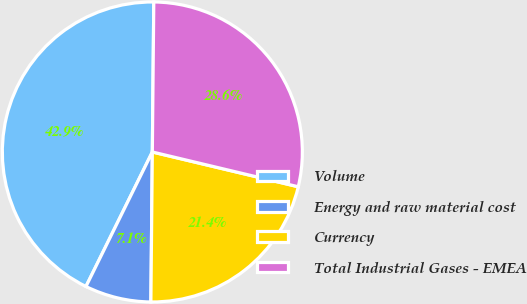Convert chart. <chart><loc_0><loc_0><loc_500><loc_500><pie_chart><fcel>Volume<fcel>Energy and raw material cost<fcel>Currency<fcel>Total Industrial Gases - EMEA<nl><fcel>42.86%<fcel>7.14%<fcel>21.43%<fcel>28.57%<nl></chart> 